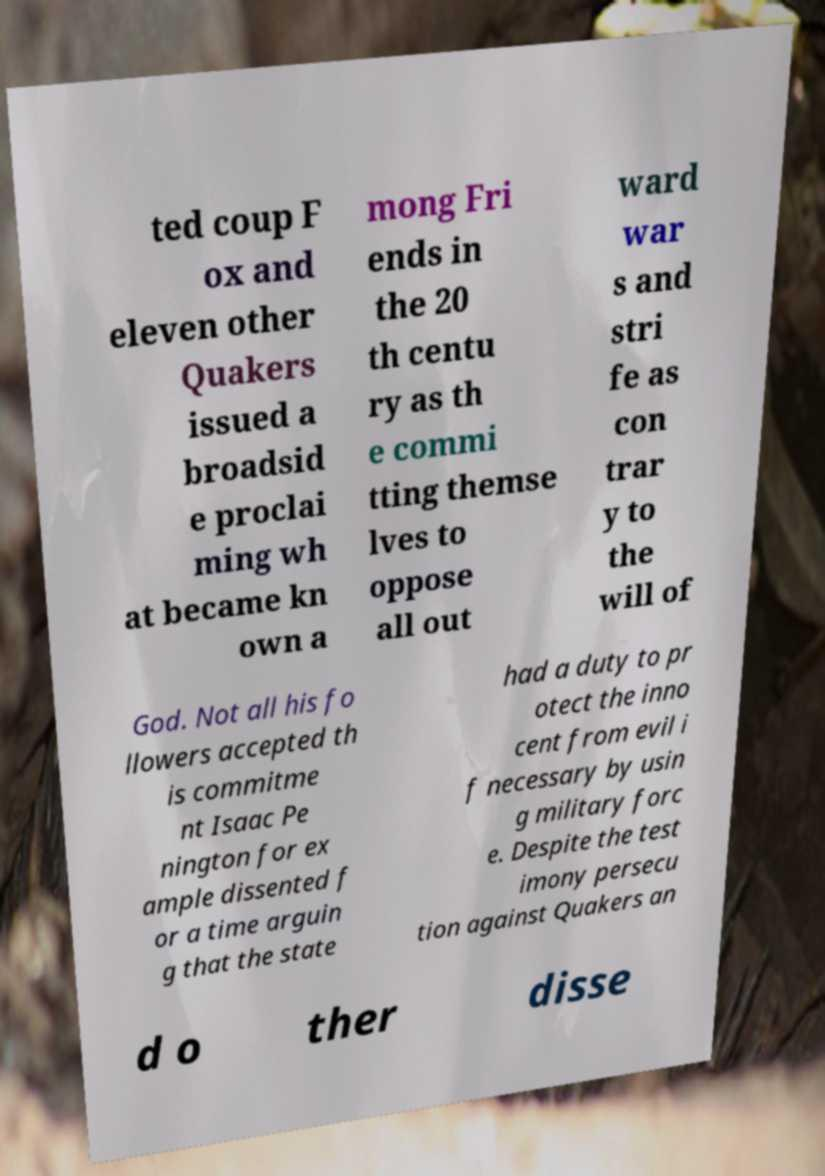Could you extract and type out the text from this image? ted coup F ox and eleven other Quakers issued a broadsid e proclai ming wh at became kn own a mong Fri ends in the 20 th centu ry as th e commi tting themse lves to oppose all out ward war s and stri fe as con trar y to the will of God. Not all his fo llowers accepted th is commitme nt Isaac Pe nington for ex ample dissented f or a time arguin g that the state had a duty to pr otect the inno cent from evil i f necessary by usin g military forc e. Despite the test imony persecu tion against Quakers an d o ther disse 